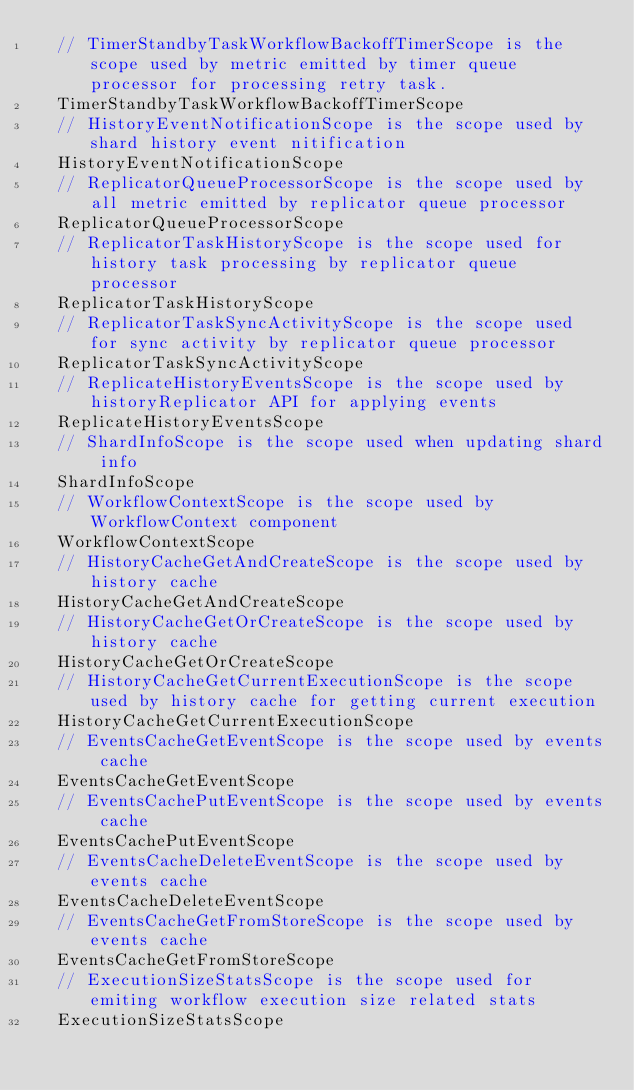Convert code to text. <code><loc_0><loc_0><loc_500><loc_500><_Go_>	// TimerStandbyTaskWorkflowBackoffTimerScope is the scope used by metric emitted by timer queue processor for processing retry task.
	TimerStandbyTaskWorkflowBackoffTimerScope
	// HistoryEventNotificationScope is the scope used by shard history event nitification
	HistoryEventNotificationScope
	// ReplicatorQueueProcessorScope is the scope used by all metric emitted by replicator queue processor
	ReplicatorQueueProcessorScope
	// ReplicatorTaskHistoryScope is the scope used for history task processing by replicator queue processor
	ReplicatorTaskHistoryScope
	// ReplicatorTaskSyncActivityScope is the scope used for sync activity by replicator queue processor
	ReplicatorTaskSyncActivityScope
	// ReplicateHistoryEventsScope is the scope used by historyReplicator API for applying events
	ReplicateHistoryEventsScope
	// ShardInfoScope is the scope used when updating shard info
	ShardInfoScope
	// WorkflowContextScope is the scope used by WorkflowContext component
	WorkflowContextScope
	// HistoryCacheGetAndCreateScope is the scope used by history cache
	HistoryCacheGetAndCreateScope
	// HistoryCacheGetOrCreateScope is the scope used by history cache
	HistoryCacheGetOrCreateScope
	// HistoryCacheGetCurrentExecutionScope is the scope used by history cache for getting current execution
	HistoryCacheGetCurrentExecutionScope
	// EventsCacheGetEventScope is the scope used by events cache
	EventsCacheGetEventScope
	// EventsCachePutEventScope is the scope used by events cache
	EventsCachePutEventScope
	// EventsCacheDeleteEventScope is the scope used by events cache
	EventsCacheDeleteEventScope
	// EventsCacheGetFromStoreScope is the scope used by events cache
	EventsCacheGetFromStoreScope
	// ExecutionSizeStatsScope is the scope used for emiting workflow execution size related stats
	ExecutionSizeStatsScope</code> 